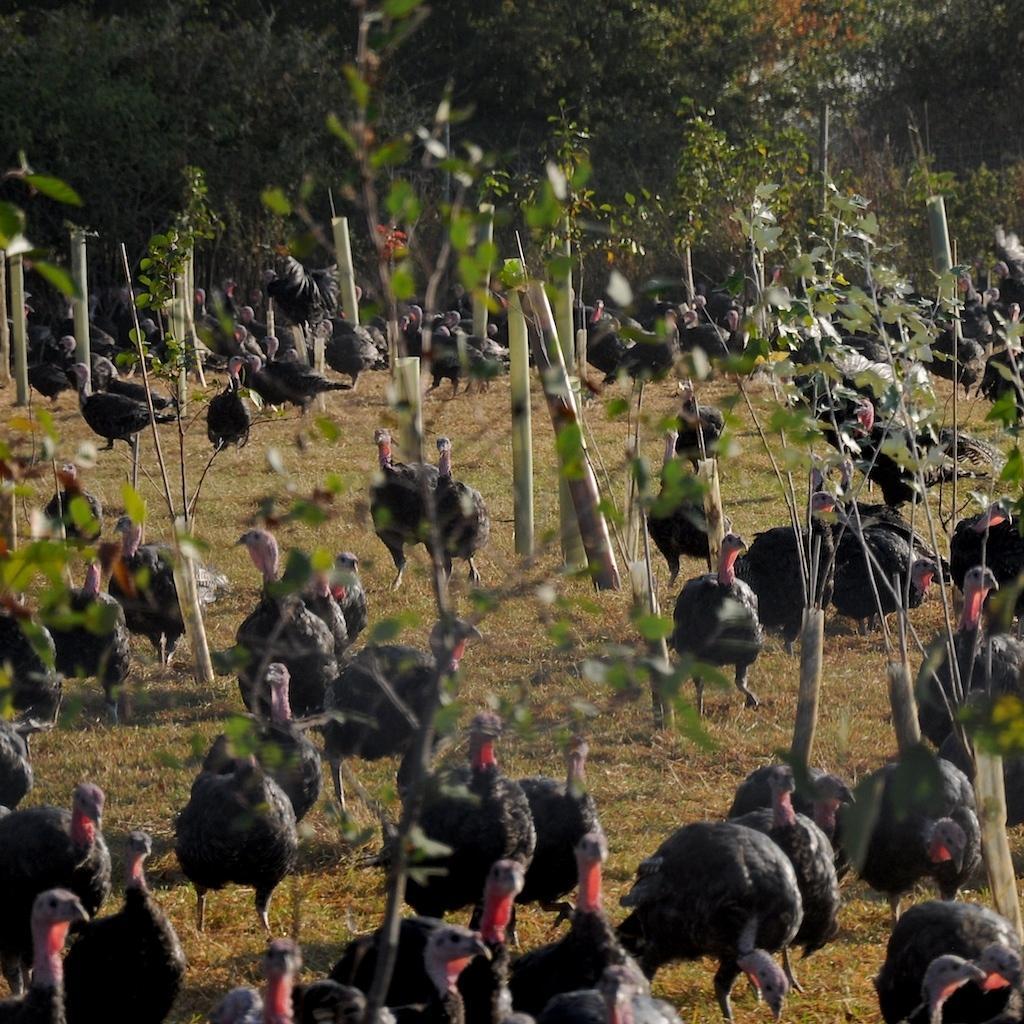How would you summarize this image in a sentence or two? In this image there are so many emu birds on the ground and some plants in the middle, behind them there are so many trees. 